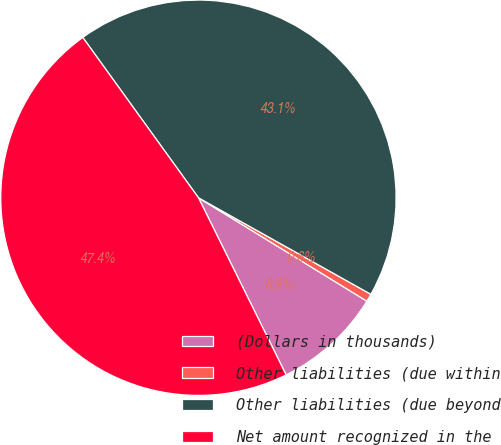Convert chart to OTSL. <chart><loc_0><loc_0><loc_500><loc_500><pie_chart><fcel>(Dollars in thousands)<fcel>Other liabilities (due within<fcel>Other liabilities (due beyond<fcel>Net amount recognized in the<nl><fcel>8.92%<fcel>0.64%<fcel>43.07%<fcel>47.37%<nl></chart> 